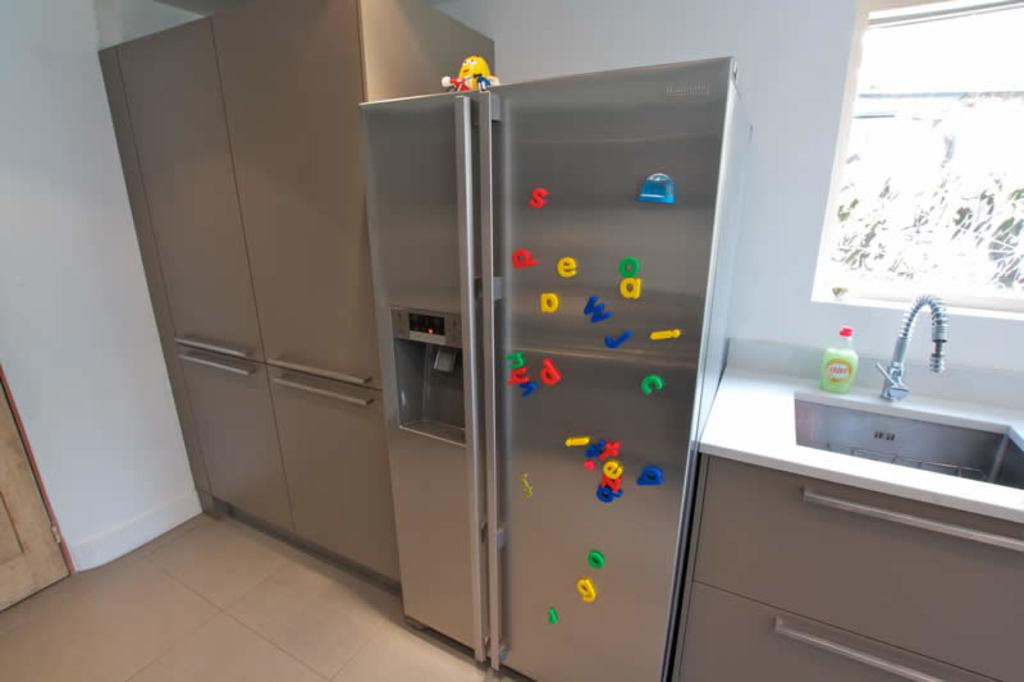Provide a one-sentence caption for the provided image. Alphabet magnets with lowercase letters such as g, w, and j are scattered across a silver colored refrigerator in a kitchen. 